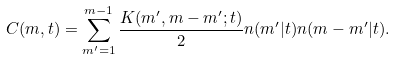Convert formula to latex. <formula><loc_0><loc_0><loc_500><loc_500>C ( m , t ) = \sum _ { m ^ { \prime } = 1 } ^ { m - 1 } \frac { K ( m ^ { \prime } , m - m ^ { \prime } ; t ) } { 2 } n ( m ^ { \prime } | t ) n ( m - m ^ { \prime } | t ) .</formula> 